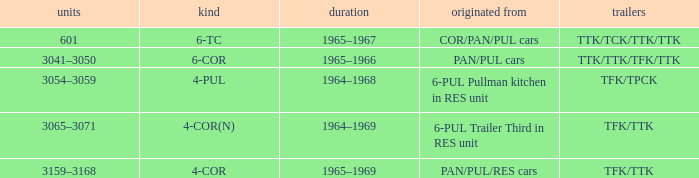Name the trailers for formed from pan/pul/res cars TFK/TTK. 